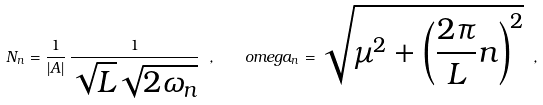Convert formula to latex. <formula><loc_0><loc_0><loc_500><loc_500>N _ { n } = \frac { 1 } { | A | } \, \frac { 1 } { \sqrt { L } \sqrt { 2 \omega _ { n } } } \ , \ \ \ o m e g a _ { n } = \sqrt { \mu ^ { 2 } + \left ( \frac { 2 \pi } { L } n \right ) ^ { 2 } } \ ,</formula> 